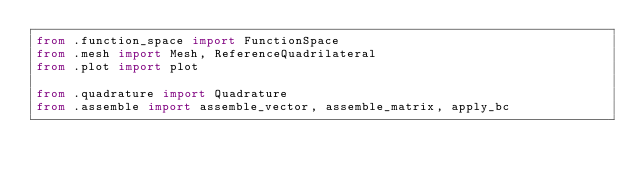<code> <loc_0><loc_0><loc_500><loc_500><_Python_>from .function_space import FunctionSpace
from .mesh import Mesh, ReferenceQuadrilateral
from .plot import plot

from .quadrature import Quadrature
from .assemble import assemble_vector, assemble_matrix, apply_bc
</code> 